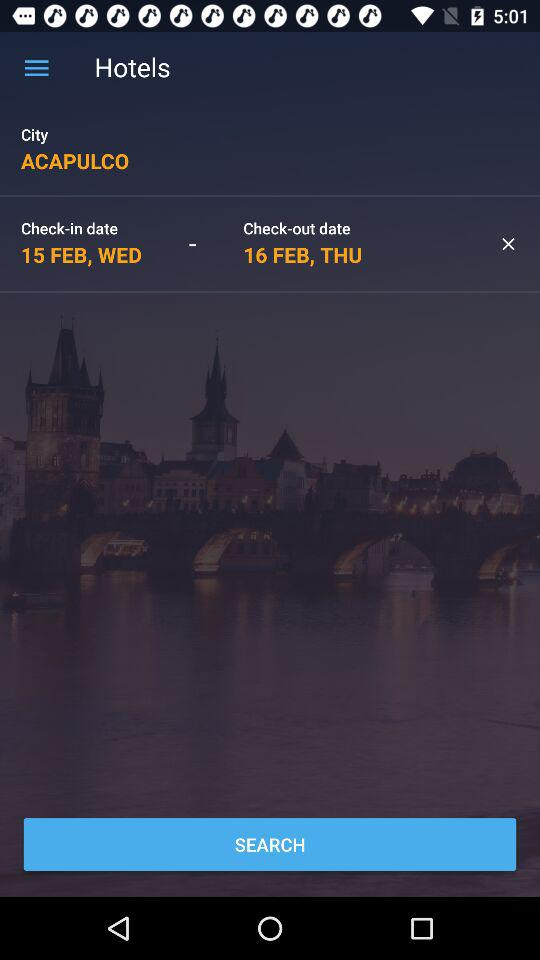What is the city name? The city name is "ACAPULCO". 